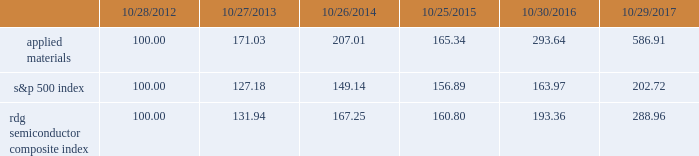Performance graph the performance graph below shows the five-year cumulative total stockholder return on applied common stock during the period from october 28 , 2012 through october 29 , 2017 .
This is compared with the cumulative total return of the standard & poor 2019s 500 stock index and the rdg semiconductor composite index over the same period .
The comparison assumes $ 100 was invested on october 28 , 2012 in applied common stock and in each of the foregoing indices and assumes reinvestment of dividends , if any .
Dollar amounts in the graph are rounded to the nearest whole dollar .
The performance shown in the graph represents past performance and should not be considered an indication of future performance .
Comparison of 5 year cumulative total return* among applied materials , inc. , the s&p 500 index and the rdg semiconductor composite index *assumes $ 100 invested on 10/28/12 in stock or 10/31/12 in index , including reinvestment of dividends .
Indexes calculated on month-end basis .
Copyright a9 2017 standard & poor 2019s , a division of s&p global .
All rights reserved. .
Dividends during each of fiscal 2017 , 2016 and 2015 , applied 2019s board of directors declared four quarterly cash dividends in the amount of $ 0.10 per share .
Applied currently anticipates that cash dividends will continue to be paid on a quarterly basis , although the declaration of any future cash dividend is at the discretion of the board of directors and will depend on applied 2019s financial condition , results of operations , capital requirements , business conditions and other factors , as well as a determination by the board of directors that cash dividends are in the best interests of applied 2019s stockholders .
10/28/12 10/27/13 10/26/14 10/25/15 10/30/16 10/29/17 applied materials , inc .
S&p 500 rdg semiconductor composite .
How much percent did the investor make on applied materials from the first 5 years compared to the 2016 to 2017 time period ? ( not including compound interest )? 
Rationale: to see the difference between the years one will need to calculate the total percentage change over those years . for the first 5 years its pretty easy because we started with $ 100 making it a 193% return . for the years 2016 to 2017 , one needs to subtract the starting price by the ending price and then divide that number by the starting price . this gives us a 99.9% return in 2016 to 2017 .
Computations: ((293.64 - 100) - ((586.91 - 293.64) / 293.64))
Answer: 192.64126. 